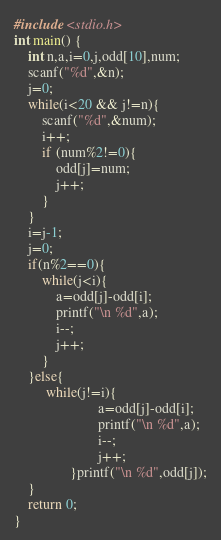Convert code to text. <code><loc_0><loc_0><loc_500><loc_500><_C_>#include <stdio.h>
int main() {
	int n,a,i=0,j,odd[10],num;
	scanf("%d",&n);
	j=0;
	while(i<20 && j!=n){
		scanf("%d",&num);
		i++;
		if (num%2!=0){
			odd[j]=num;
			j++;
		}
	}
	i=j-1;
	j=0;
	if(n%2==0){
		while(j<i){
			a=odd[j]-odd[i];
			printf("\n %d",a);
			i--;
			j++;
		}
	}else{
		 while(j!=i){
                        a=odd[j]-odd[i];
                        printf("\n %d",a);
                        i--;
                        j++;
                }printf("\n %d",odd[j]);
	}
	return 0;
}
</code> 